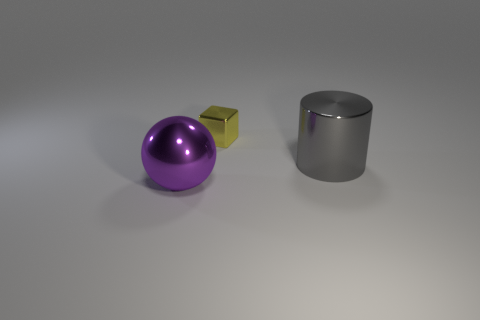Add 1 big red rubber objects. How many objects exist? 4 Subtract all cylinders. How many objects are left? 2 Add 2 tiny yellow shiny objects. How many tiny yellow shiny objects are left? 3 Add 3 small gray metallic blocks. How many small gray metallic blocks exist? 3 Subtract 0 gray blocks. How many objects are left? 3 Subtract all small blue things. Subtract all large gray metallic cylinders. How many objects are left? 2 